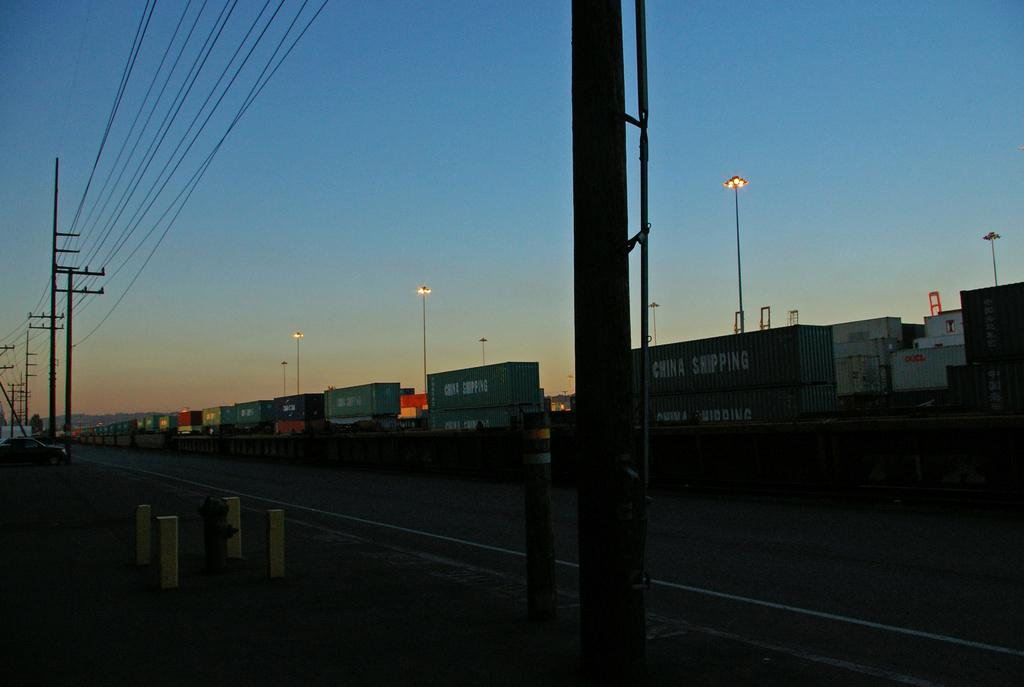What objects are present in the image that resemble storage or holding units? There are containers in the image. What type of pathway can be seen in the image? There is a road in the image. What architectural elements are visible in the image? There are pillars in the image. What safety feature is present in the image? There is a hydrant in the image. What vertical structures can be seen in the image? There are poles in the image. What type of transportation is visible in the image? There is a vehicle in the image. What type of electrical infrastructure is present in the image? There are wires in the image. What type of illumination is present in the image? There are lights in the image. What can be seen in the background of the image, indicating the weather or time of day? The sky is clear in the background of the image. Where is the monkey hanging from the hook in the image? There is no monkey or hook present in the image. What is the value of the item being sold in the image? There is no item being sold in the image. 